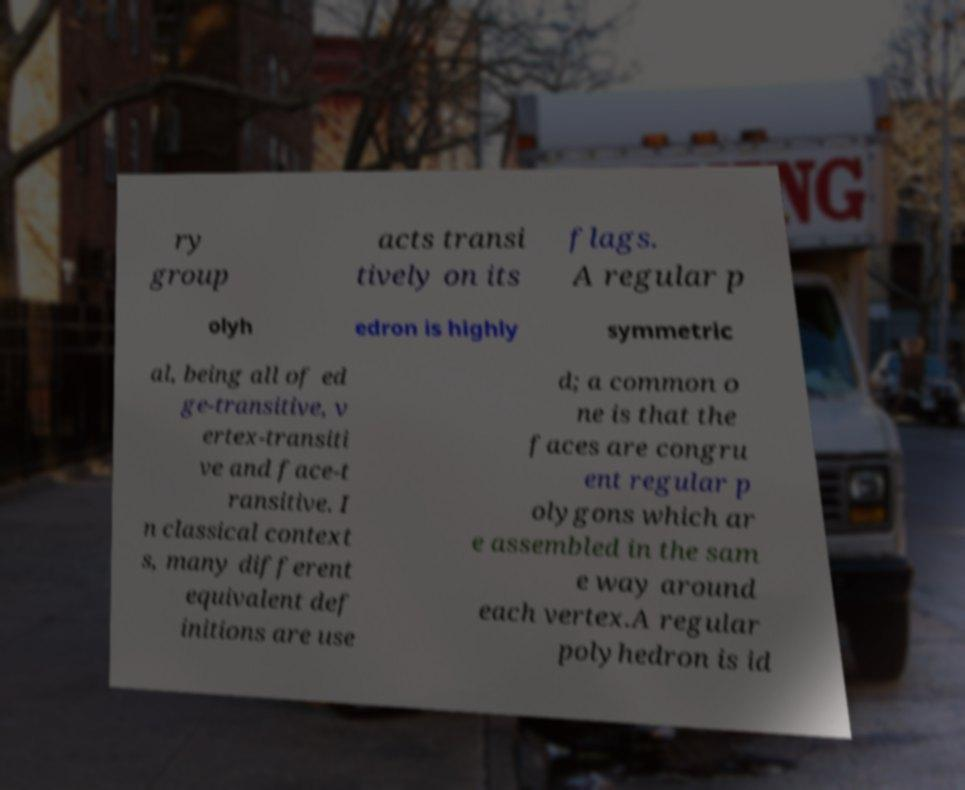Please read and relay the text visible in this image. What does it say? ry group acts transi tively on its flags. A regular p olyh edron is highly symmetric al, being all of ed ge-transitive, v ertex-transiti ve and face-t ransitive. I n classical context s, many different equivalent def initions are use d; a common o ne is that the faces are congru ent regular p olygons which ar e assembled in the sam e way around each vertex.A regular polyhedron is id 